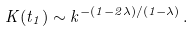<formula> <loc_0><loc_0><loc_500><loc_500>K ( t _ { 1 } ) \sim k ^ { - ( 1 - 2 \lambda ) / ( 1 - \lambda ) } \, .</formula> 